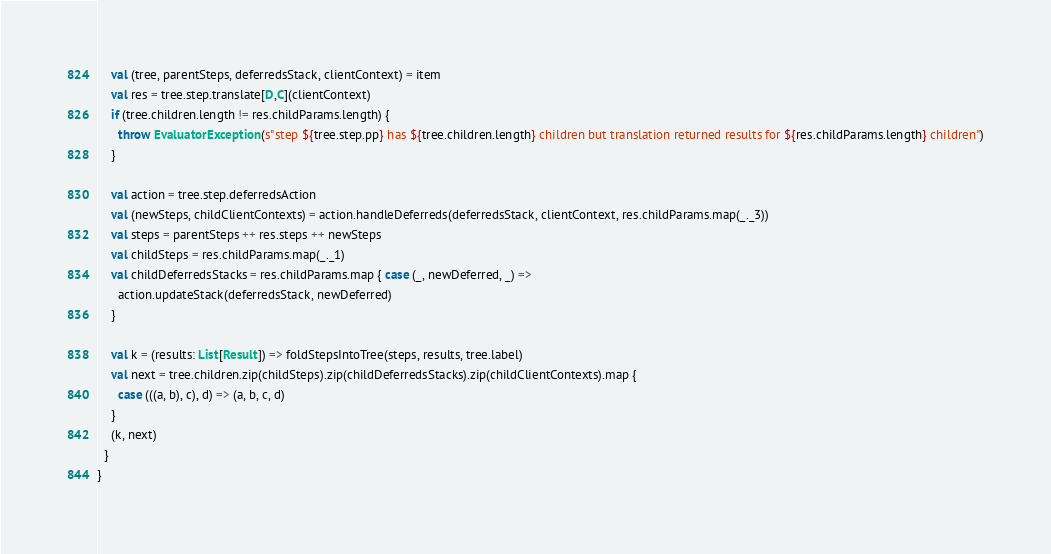Convert code to text. <code><loc_0><loc_0><loc_500><loc_500><_Scala_>    val (tree, parentSteps, deferredsStack, clientContext) = item
    val res = tree.step.translate[D,C](clientContext)
    if (tree.children.length != res.childParams.length) {
      throw EvaluatorException(s"step ${tree.step.pp} has ${tree.children.length} children but translation returned results for ${res.childParams.length} children")
    }

    val action = tree.step.deferredsAction
    val (newSteps, childClientContexts) = action.handleDeferreds(deferredsStack, clientContext, res.childParams.map(_._3))
    val steps = parentSteps ++ res.steps ++ newSteps
    val childSteps = res.childParams.map(_._1)
    val childDeferredsStacks = res.childParams.map { case (_, newDeferred, _) =>
      action.updateStack(deferredsStack, newDeferred)
    }

    val k = (results: List[Result]) => foldStepsIntoTree(steps, results, tree.label)
    val next = tree.children.zip(childSteps).zip(childDeferredsStacks).zip(childClientContexts).map {
      case (((a, b), c), d) => (a, b, c, d)
    }
    (k, next)
  }
}
</code> 